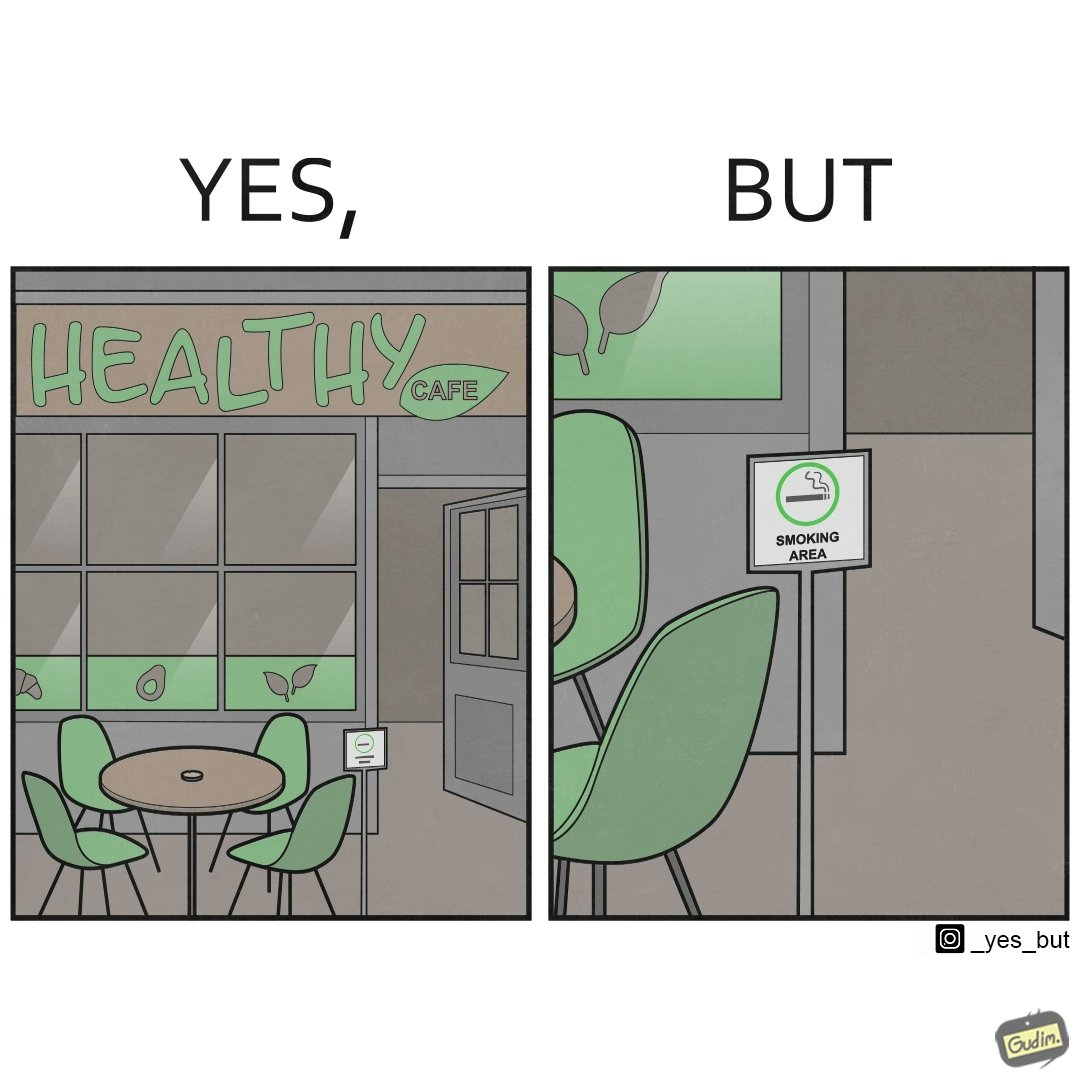Explain the humor or irony in this image. This image is funny because an eatery that calls itself the "healthy" cafe also has a smoking area, which is not very "healthy". If it really was a healthy cafe, it would not have a smoking area as smoking is injurious to health. Satire on the behavior of humans - both those that operate this cafe who made the decision of allowing smoking and creating a designated smoking area, and those that visit this healthy cafe to become "healthy", but then also indulge in very unhealthy habits simultaneously. 